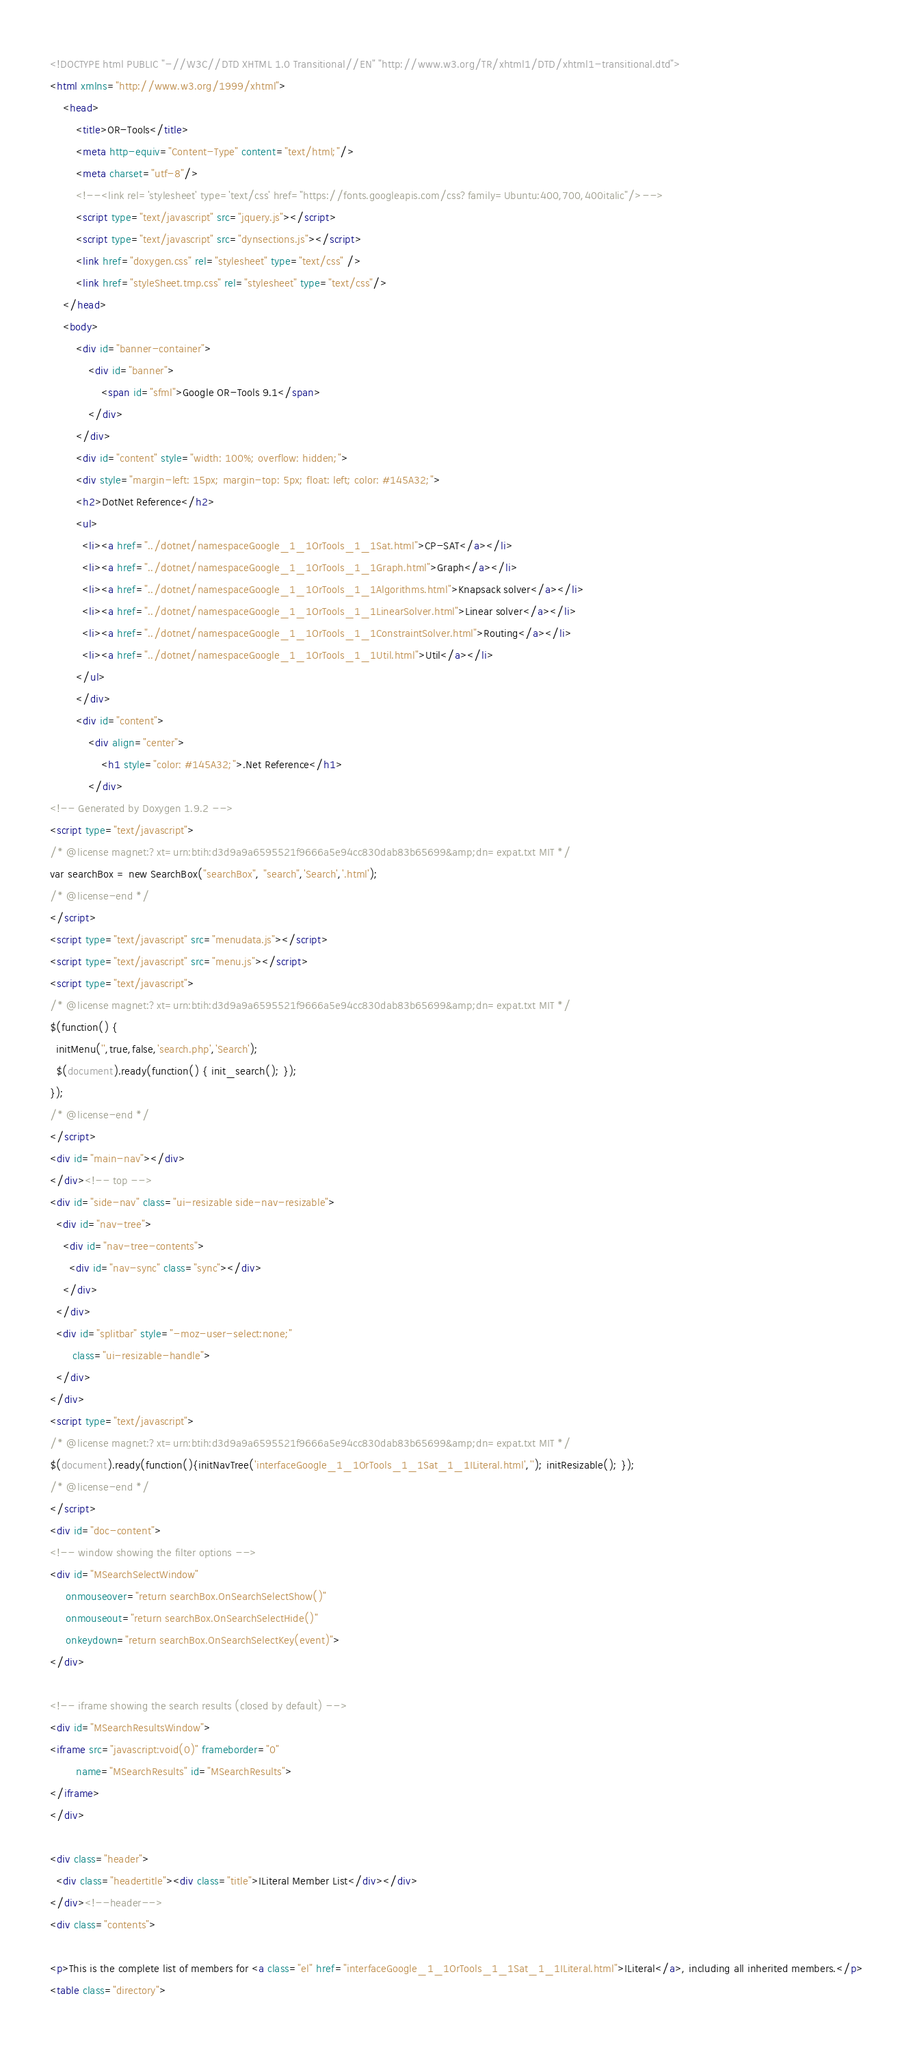<code> <loc_0><loc_0><loc_500><loc_500><_HTML_><!DOCTYPE html PUBLIC "-//W3C//DTD XHTML 1.0 Transitional//EN" "http://www.w3.org/TR/xhtml1/DTD/xhtml1-transitional.dtd">
<html xmlns="http://www.w3.org/1999/xhtml">
    <head>
        <title>OR-Tools</title>
        <meta http-equiv="Content-Type" content="text/html;"/>
        <meta charset="utf-8"/>
        <!--<link rel='stylesheet' type='text/css' href="https://fonts.googleapis.com/css?family=Ubuntu:400,700,400italic"/>-->
        <script type="text/javascript" src="jquery.js"></script>
        <script type="text/javascript" src="dynsections.js"></script>
        <link href="doxygen.css" rel="stylesheet" type="text/css" />
        <link href="styleSheet.tmp.css" rel="stylesheet" type="text/css"/>
    </head>
    <body>
        <div id="banner-container">
            <div id="banner">
                <span id="sfml">Google OR-Tools 9.1</span>
            </div>
        </div>
        <div id="content" style="width: 100%; overflow: hidden;">
        <div style="margin-left: 15px; margin-top: 5px; float: left; color: #145A32;">
        <h2>DotNet Reference</h2>
        <ul>
          <li><a href="../dotnet/namespaceGoogle_1_1OrTools_1_1Sat.html">CP-SAT</a></li>
          <li><a href="../dotnet/namespaceGoogle_1_1OrTools_1_1Graph.html">Graph</a></li>
          <li><a href="../dotnet/namespaceGoogle_1_1OrTools_1_1Algorithms.html">Knapsack solver</a></li>
          <li><a href="../dotnet/namespaceGoogle_1_1OrTools_1_1LinearSolver.html">Linear solver</a></li>
          <li><a href="../dotnet/namespaceGoogle_1_1OrTools_1_1ConstraintSolver.html">Routing</a></li>
          <li><a href="../dotnet/namespaceGoogle_1_1OrTools_1_1Util.html">Util</a></li>
        </ul>
        </div>
        <div id="content">
            <div align="center">
                <h1 style="color: #145A32;">.Net Reference</h1>
            </div>
<!-- Generated by Doxygen 1.9.2 -->
<script type="text/javascript">
/* @license magnet:?xt=urn:btih:d3d9a9a6595521f9666a5e94cc830dab83b65699&amp;dn=expat.txt MIT */
var searchBox = new SearchBox("searchBox", "search",'Search','.html');
/* @license-end */
</script>
<script type="text/javascript" src="menudata.js"></script>
<script type="text/javascript" src="menu.js"></script>
<script type="text/javascript">
/* @license magnet:?xt=urn:btih:d3d9a9a6595521f9666a5e94cc830dab83b65699&amp;dn=expat.txt MIT */
$(function() {
  initMenu('',true,false,'search.php','Search');
  $(document).ready(function() { init_search(); });
});
/* @license-end */
</script>
<div id="main-nav"></div>
</div><!-- top -->
<div id="side-nav" class="ui-resizable side-nav-resizable">
  <div id="nav-tree">
    <div id="nav-tree-contents">
      <div id="nav-sync" class="sync"></div>
    </div>
  </div>
  <div id="splitbar" style="-moz-user-select:none;" 
       class="ui-resizable-handle">
  </div>
</div>
<script type="text/javascript">
/* @license magnet:?xt=urn:btih:d3d9a9a6595521f9666a5e94cc830dab83b65699&amp;dn=expat.txt MIT */
$(document).ready(function(){initNavTree('interfaceGoogle_1_1OrTools_1_1Sat_1_1ILiteral.html',''); initResizable(); });
/* @license-end */
</script>
<div id="doc-content">
<!-- window showing the filter options -->
<div id="MSearchSelectWindow"
     onmouseover="return searchBox.OnSearchSelectShow()"
     onmouseout="return searchBox.OnSearchSelectHide()"
     onkeydown="return searchBox.OnSearchSelectKey(event)">
</div>

<!-- iframe showing the search results (closed by default) -->
<div id="MSearchResultsWindow">
<iframe src="javascript:void(0)" frameborder="0" 
        name="MSearchResults" id="MSearchResults">
</iframe>
</div>

<div class="header">
  <div class="headertitle"><div class="title">ILiteral Member List</div></div>
</div><!--header-->
<div class="contents">

<p>This is the complete list of members for <a class="el" href="interfaceGoogle_1_1OrTools_1_1Sat_1_1ILiteral.html">ILiteral</a>, including all inherited members.</p>
<table class="directory"></code> 